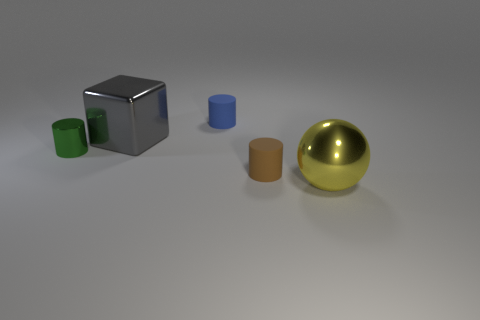Are there any other things of the same color as the shiny block?
Offer a terse response. No. What number of small gray shiny things are there?
Offer a very short reply. 0. What is the material of the green object on the left side of the small object on the right side of the blue object?
Your response must be concise. Metal. What color is the matte cylinder behind the small green cylinder that is in front of the big object that is behind the large yellow shiny thing?
Provide a short and direct response. Blue. What number of blue cylinders have the same size as the blue rubber object?
Your answer should be very brief. 0. Are there more rubber cylinders behind the gray object than gray things that are behind the metal cylinder?
Your answer should be very brief. No. What is the color of the small matte object that is in front of the large object that is behind the green cylinder?
Offer a very short reply. Brown. Are the tiny green thing and the block made of the same material?
Keep it short and to the point. Yes. Is there a big blue object of the same shape as the green object?
Keep it short and to the point. No. There is a large metal thing that is left of the big shiny ball; is it the same color as the small metallic thing?
Your answer should be very brief. No. 